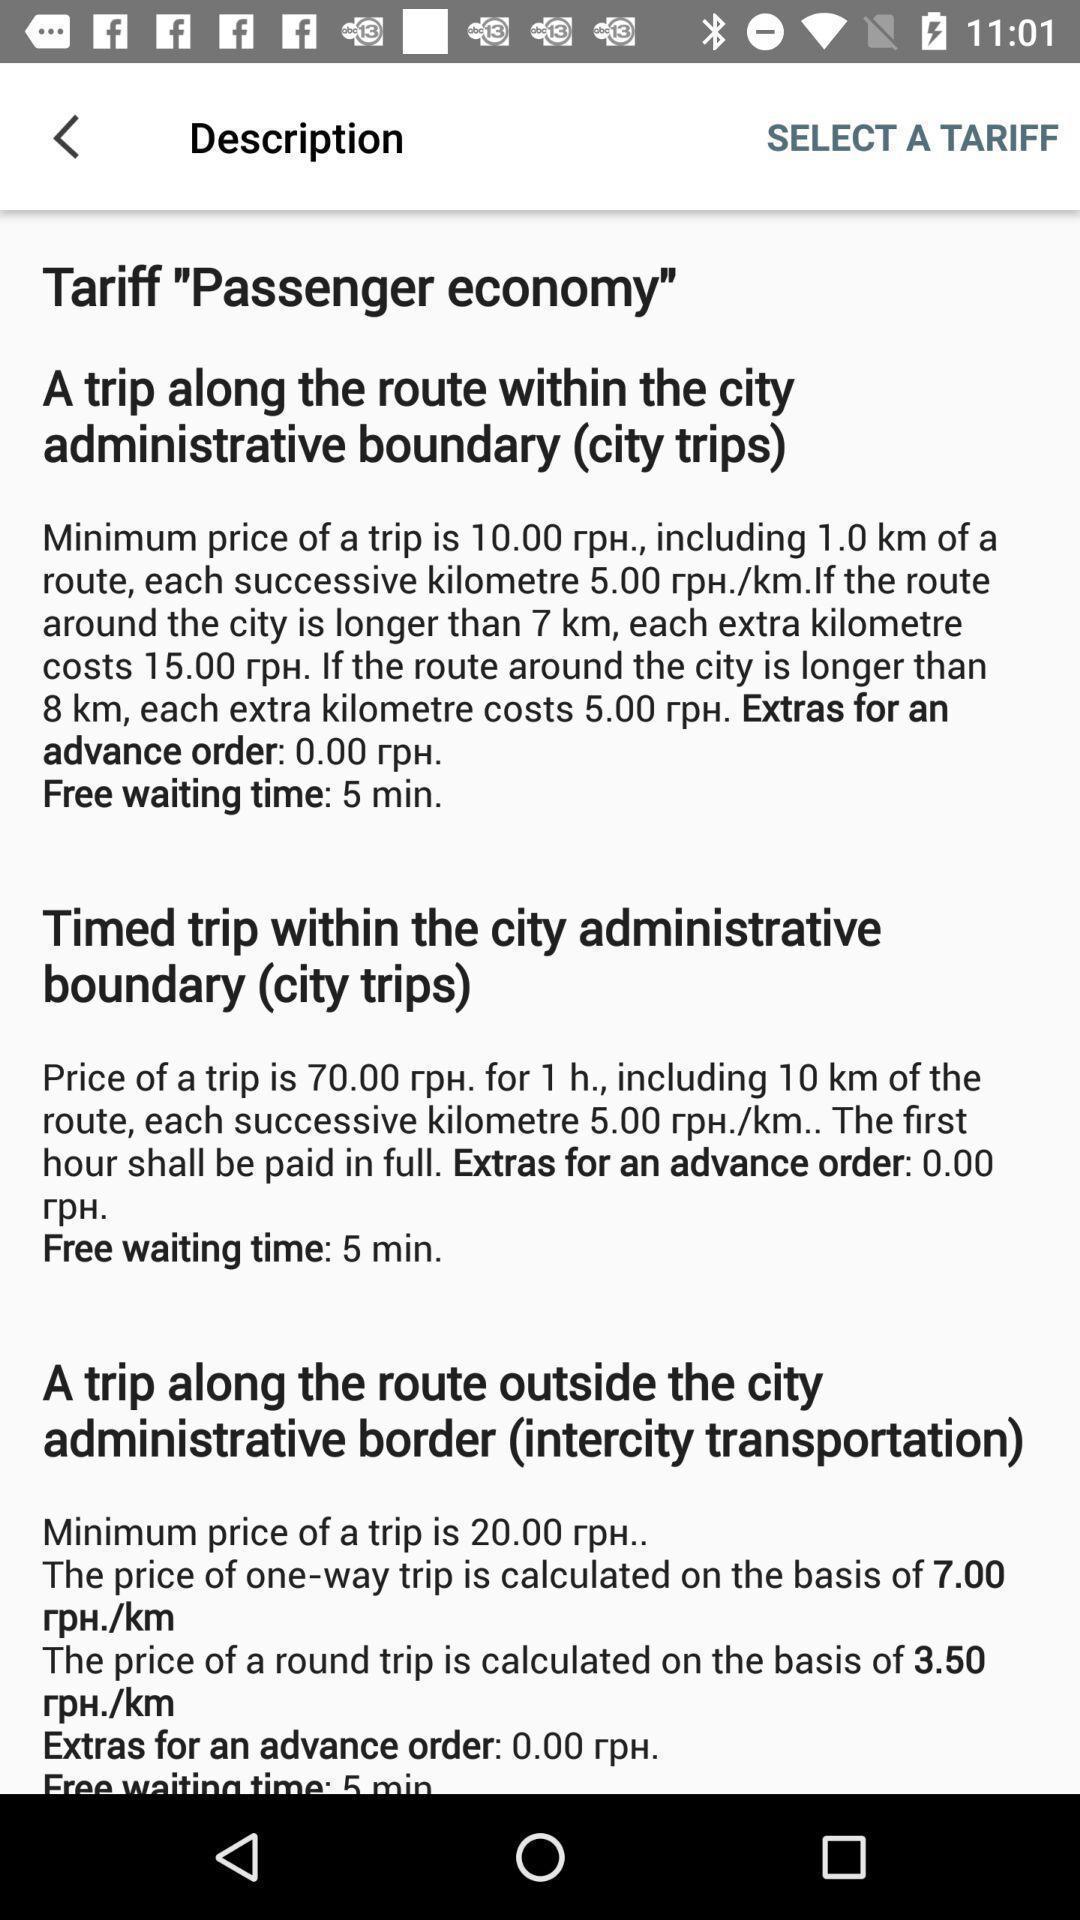Please provide a description for this image. Screen page with information. 